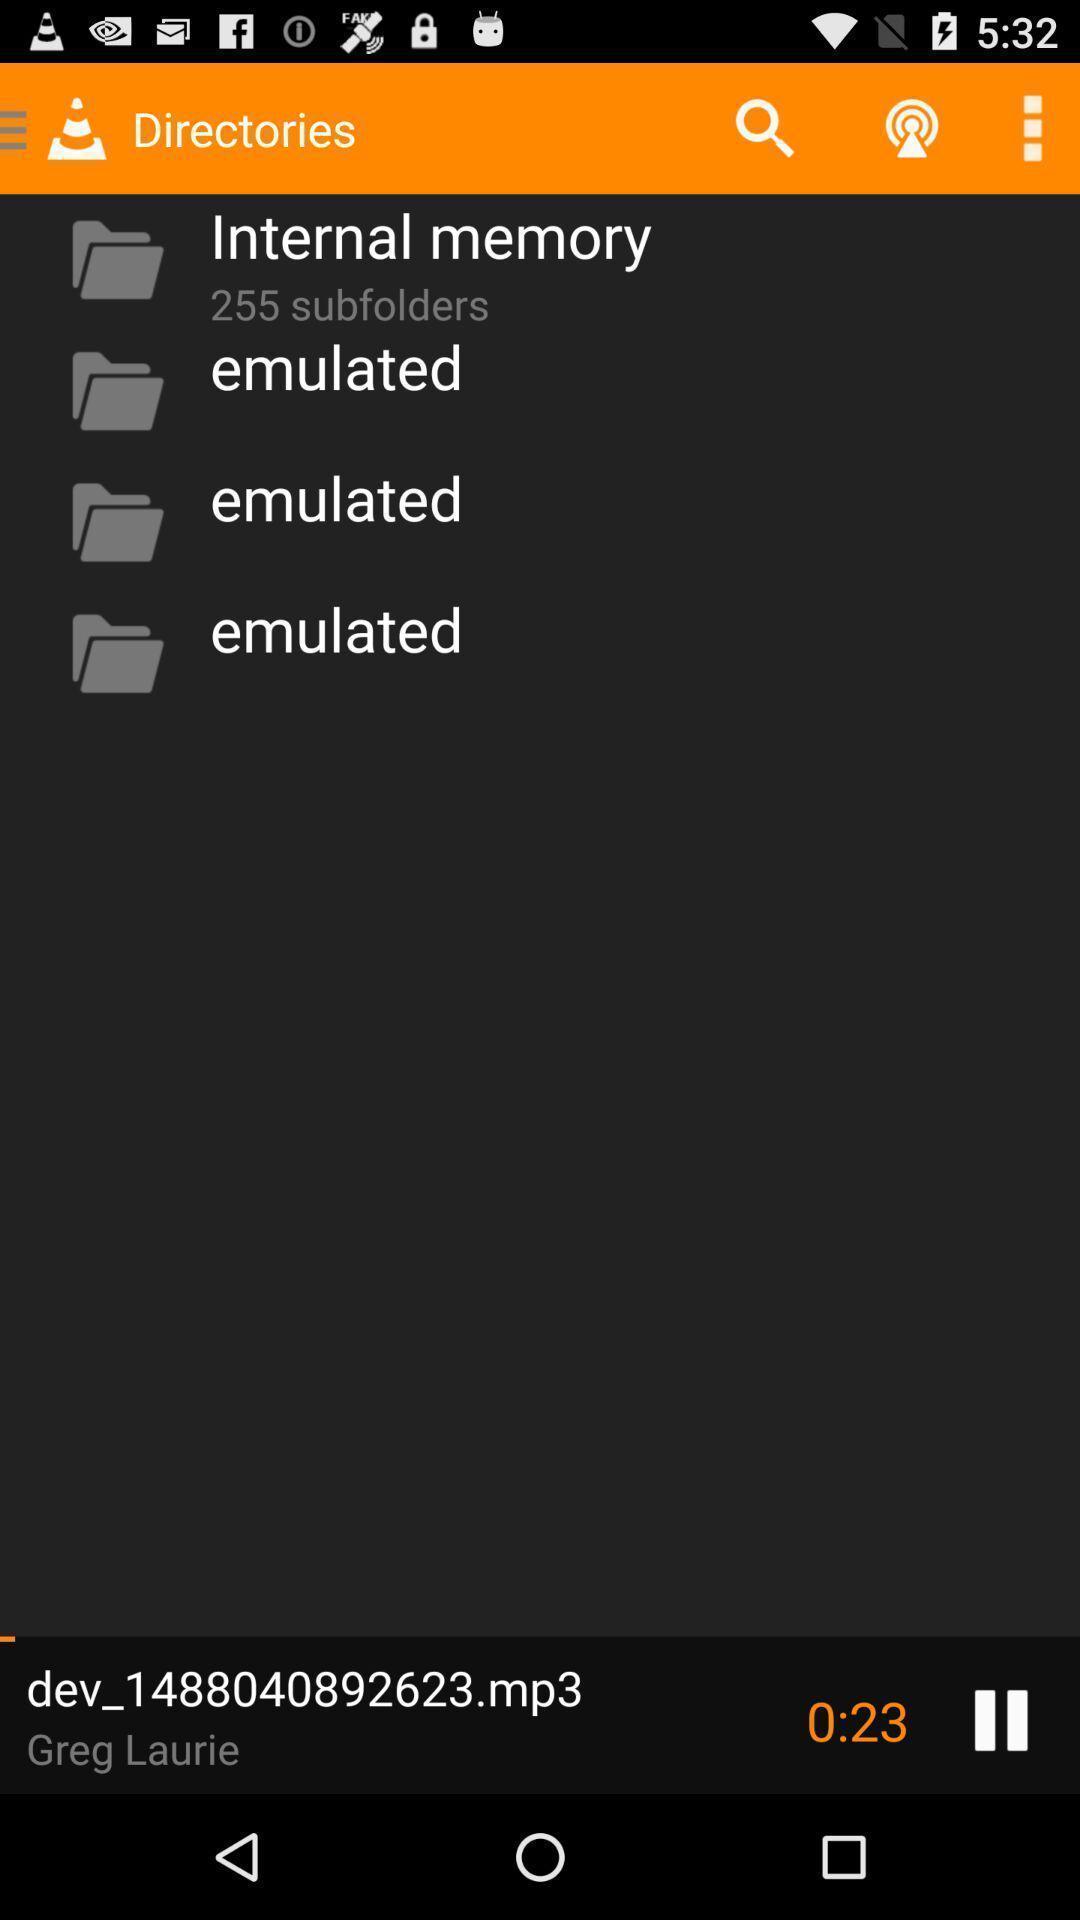Explain what's happening in this screen capture. Screen displaying the multiple folders in a music page. 